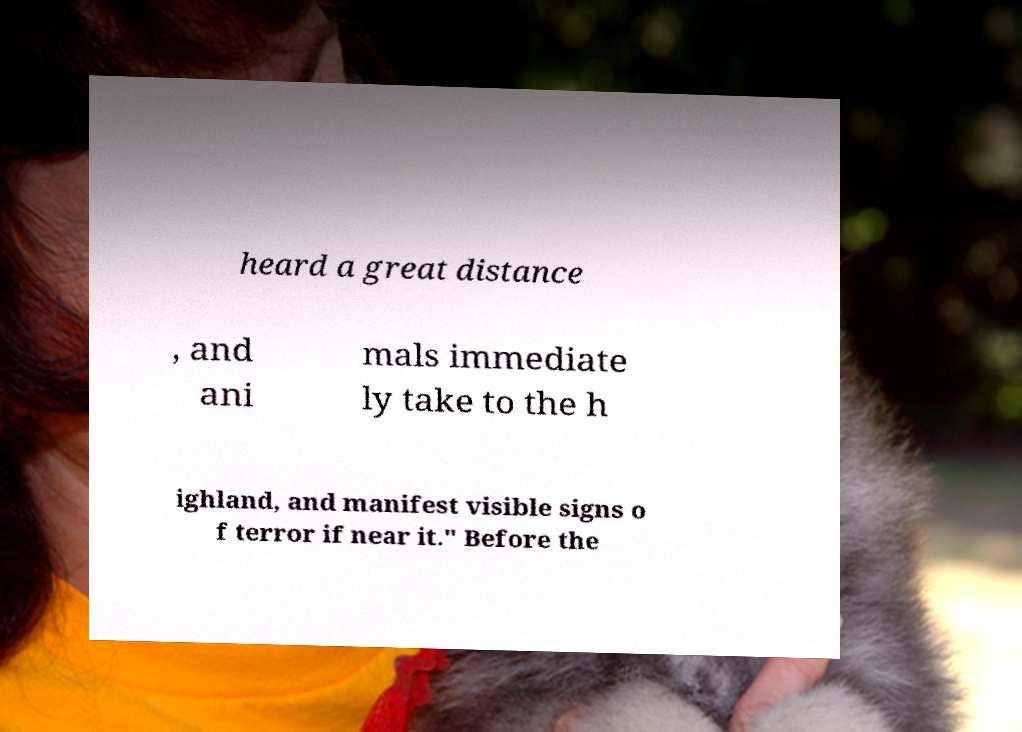For documentation purposes, I need the text within this image transcribed. Could you provide that? heard a great distance , and ani mals immediate ly take to the h ighland, and manifest visible signs o f terror if near it." Before the 